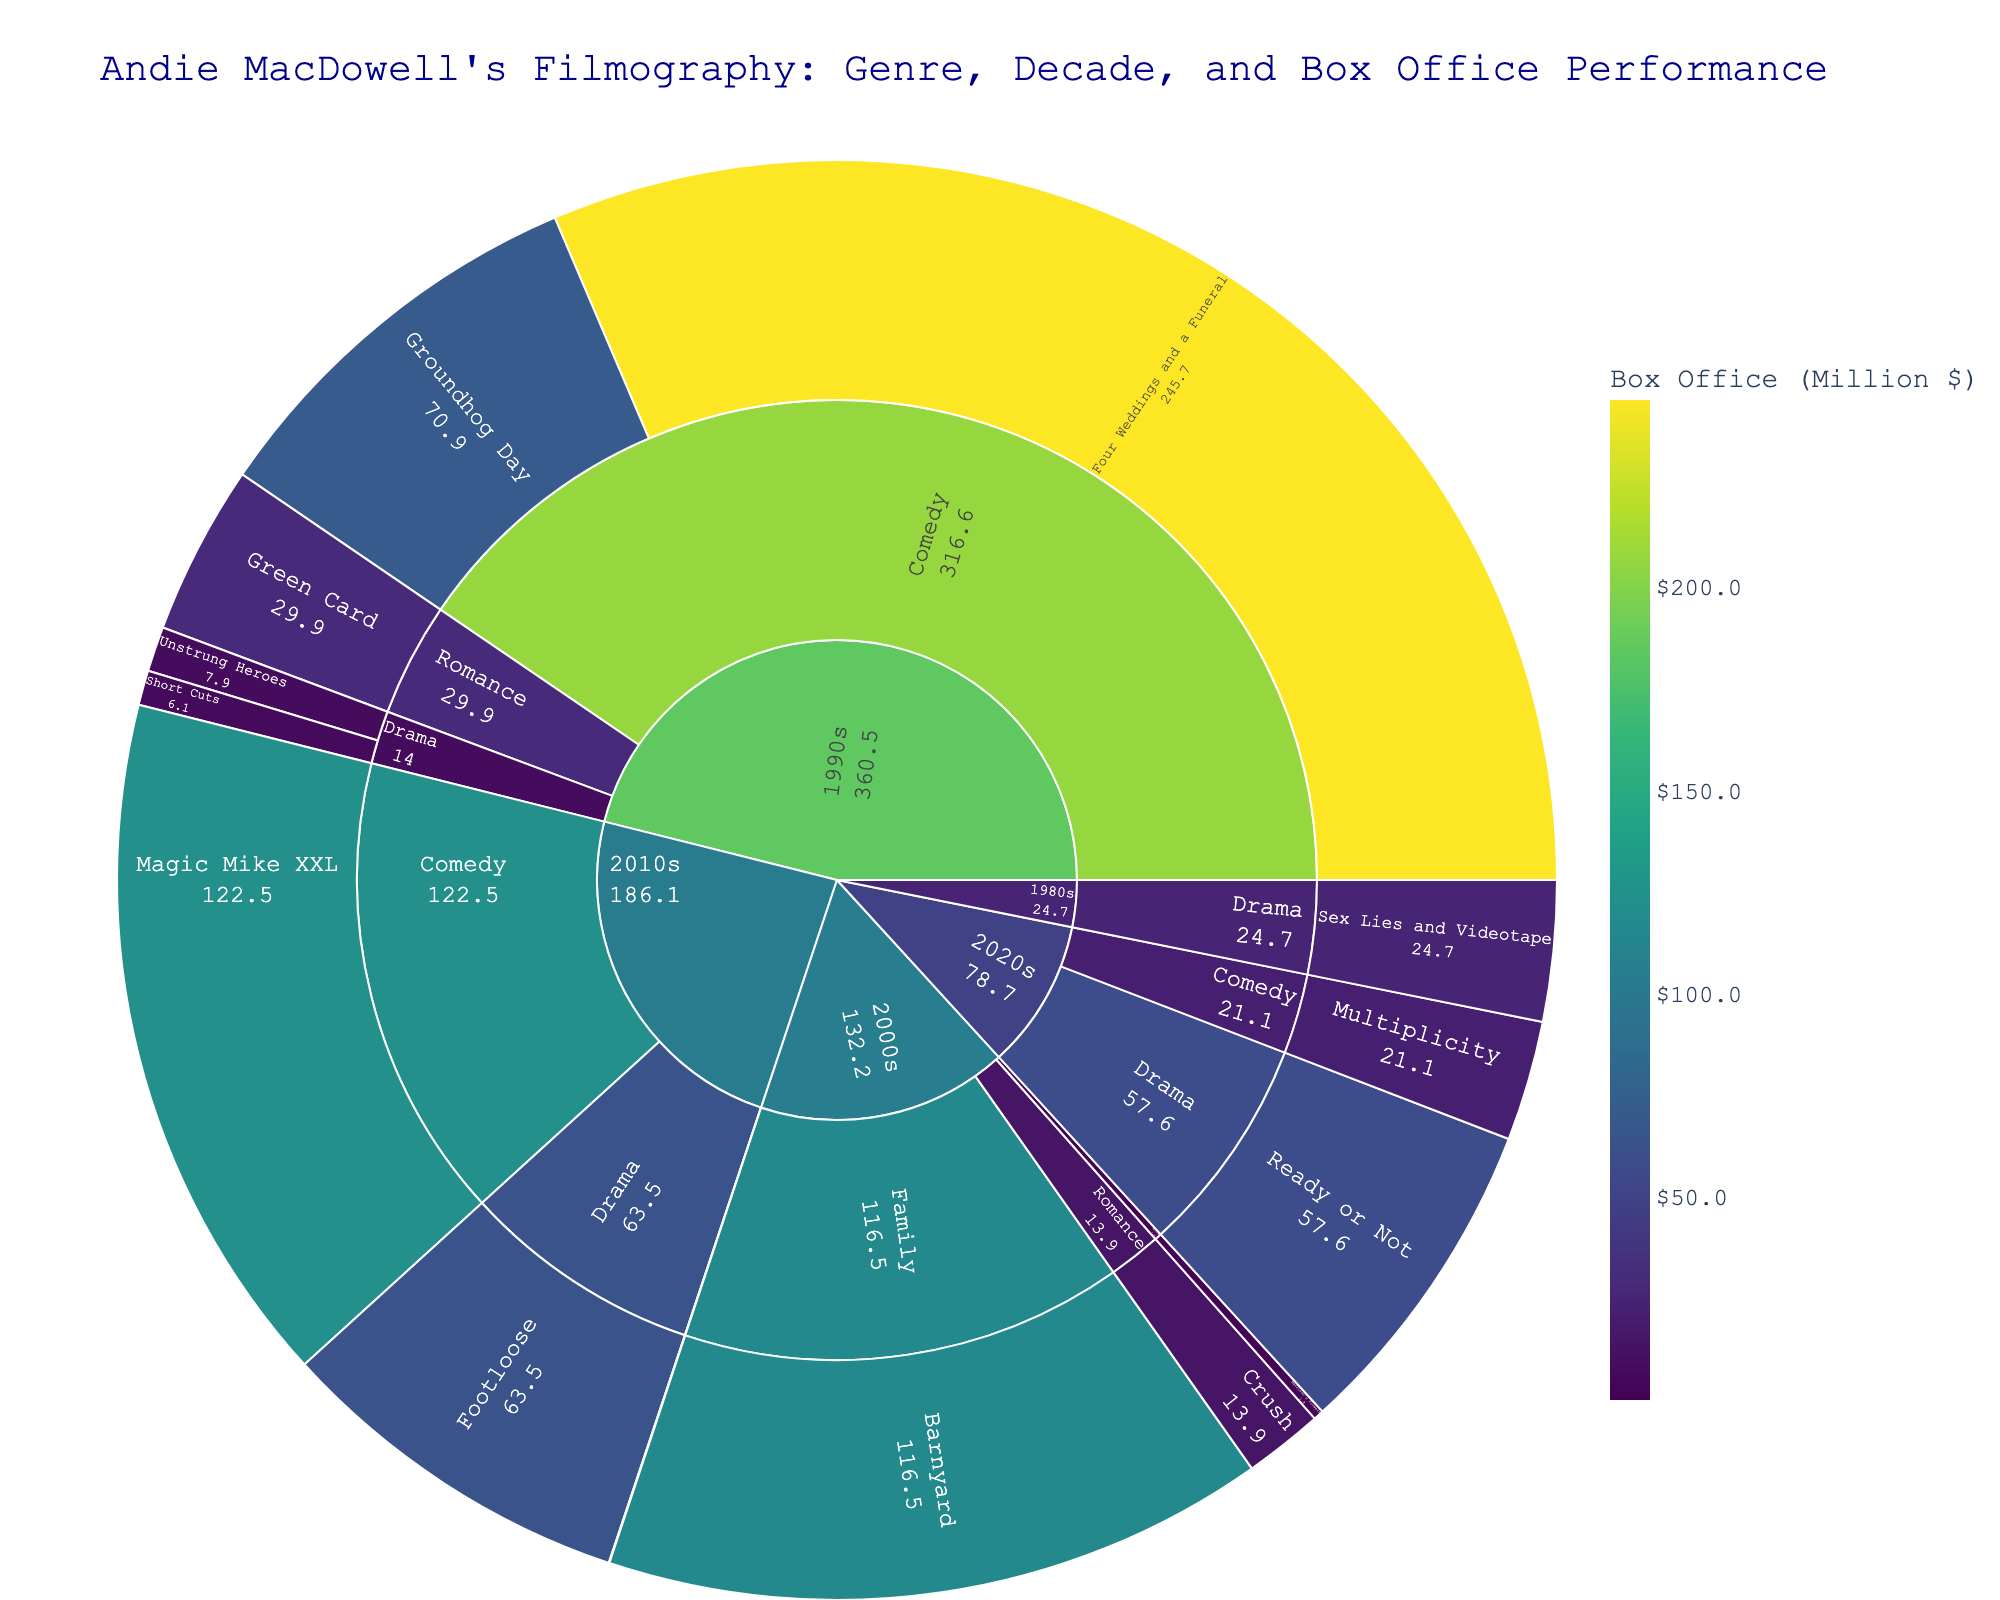What is the title of the figure? The title is usually positioned at the top of the plot and is clearly indicated.
Answer: Andie MacDowell's Filmography: Genre, Decade, and Box Office Performance Which genre in the 1990s had the highest box office performance? Look at the segments of the sunburst plot under the 1990s decade and check the box office values under each genre.
Answer: Comedy How many films are there in the 2000s? Count the number of film segments under the 2000s decade section.
Answer: 3 Among the Drama films, which one had the highest box office performance? Locate the Drama genre and compare the box office values of the films listed under it.
Answer: Footloose Which decade has the most diverse range of genres represented? Check each decade section and count the different genres listed under them.
Answer: 1990s Which film in the 2010s had the lowest box office performance? Under the 2010s decade section, look for the film with the smallest box office value segment.
Answer: Love After Love Between the Romance films in the 1990s and 2010s, which decade had higher total box office performance? Sum the box office values of Romance films in each of the two decades and compare them.
Answer: 1990s What is the average box office performance of all Comedy films? Sum the box office values of all Comedy films and divide by the number of Comedy films.
Answer: (70.9 + 245.7 + 122.5 + 21.1) / 4 = 115.05 million Which genre had the highest performing film overall? Identify the film with the highest box office value across all genres and see which genre it belongs to.
Answer: Comedy How does the box office performance of "Groundhog Day" compare to "Four Weddings and a Funeral"? Compare the box office values of these two films found under the 1990s Comedy section.
Answer: "Four Weddings and a Funeral" is higher 